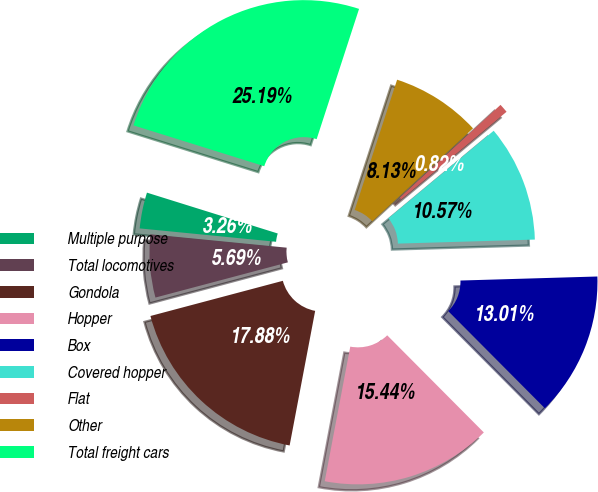Convert chart to OTSL. <chart><loc_0><loc_0><loc_500><loc_500><pie_chart><fcel>Multiple purpose<fcel>Total locomotives<fcel>Gondola<fcel>Hopper<fcel>Box<fcel>Covered hopper<fcel>Flat<fcel>Other<fcel>Total freight cars<nl><fcel>3.26%<fcel>5.69%<fcel>17.88%<fcel>15.44%<fcel>13.01%<fcel>10.57%<fcel>0.82%<fcel>8.13%<fcel>25.19%<nl></chart> 